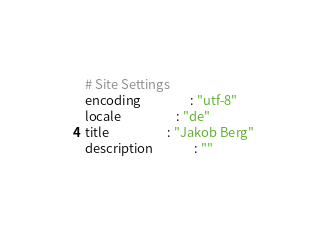<code> <loc_0><loc_0><loc_500><loc_500><_YAML_># Site Settings
encoding                 : "utf-8"
locale                   : "de"
title                    : "Jakob Berg"
description              : ""</code> 